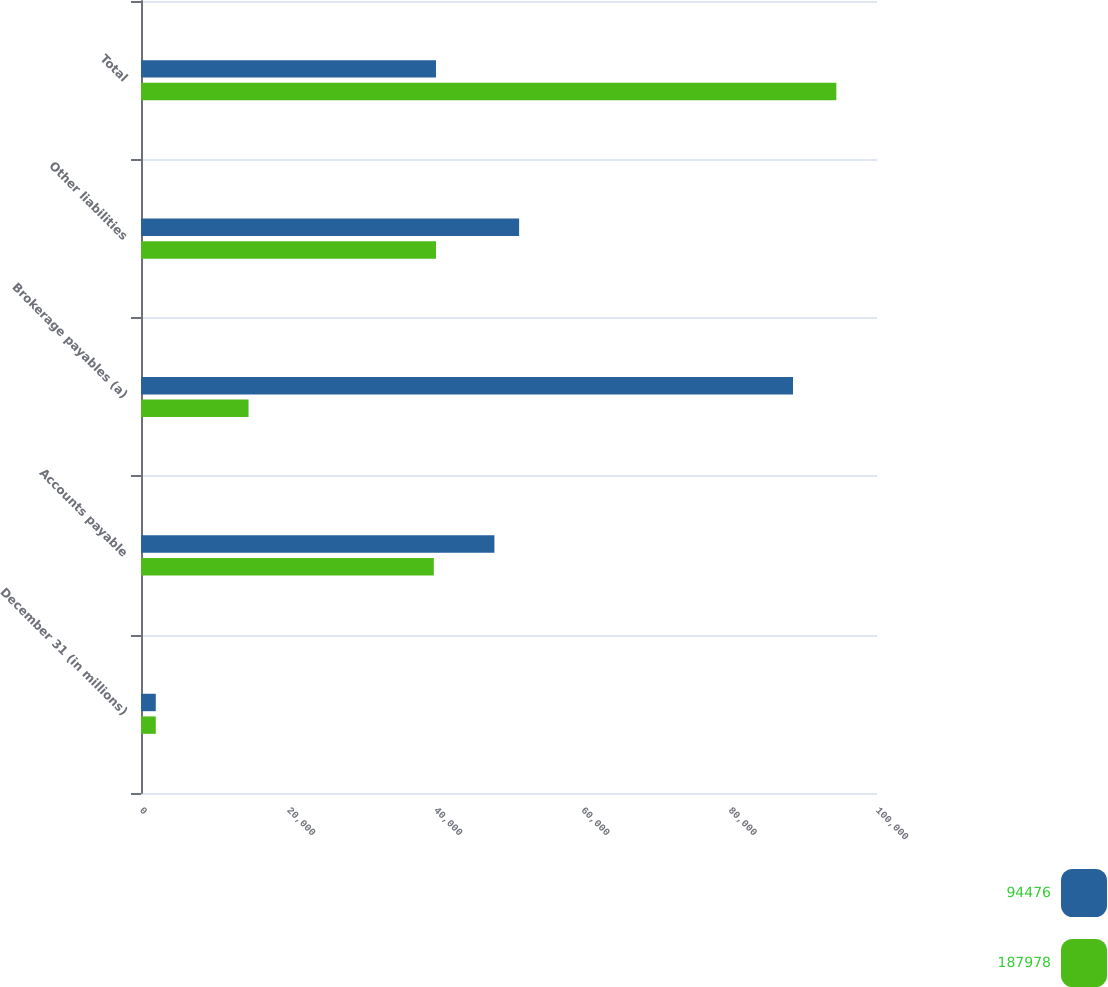<chart> <loc_0><loc_0><loc_500><loc_500><stacked_bar_chart><ecel><fcel>December 31 (in millions)<fcel>Accounts payable<fcel>Brokerage payables (a)<fcel>Other liabilities<fcel>Total<nl><fcel>94476<fcel>2008<fcel>48019<fcel>88585<fcel>51374<fcel>40079<nl><fcel>187978<fcel>2007<fcel>39785<fcel>14612<fcel>40079<fcel>94476<nl></chart> 